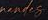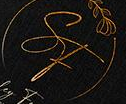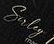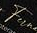What text is displayed in these images sequentially, separated by a semicolon? #####; SF; Suley; Fu 